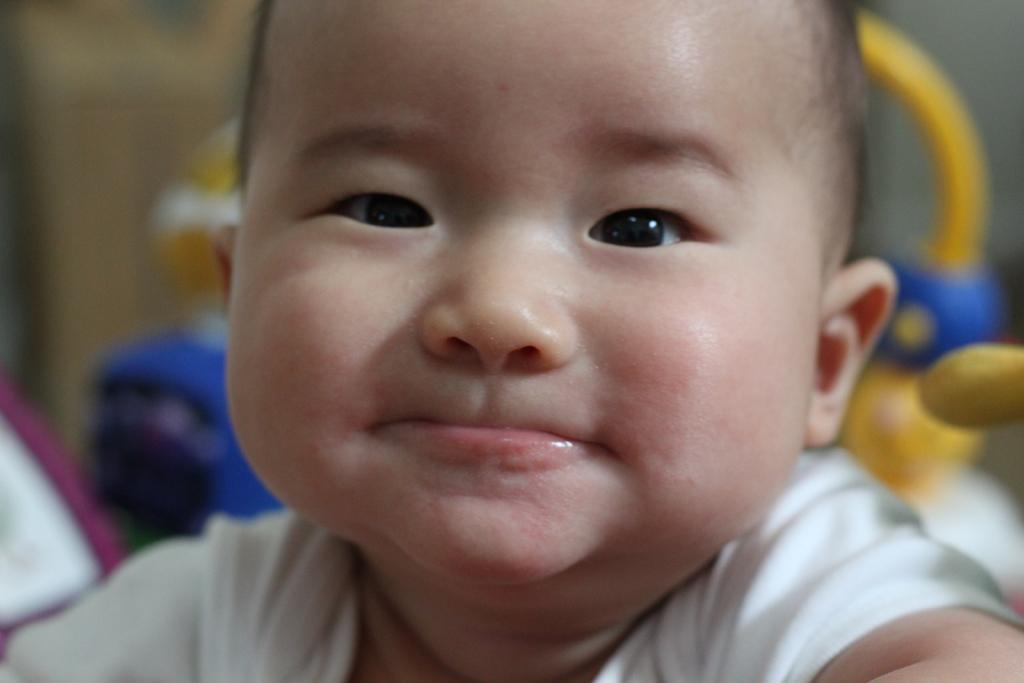Describe this image in one or two sentences. This is a baby smiling. I think these are the toys. The background looks blurry. 